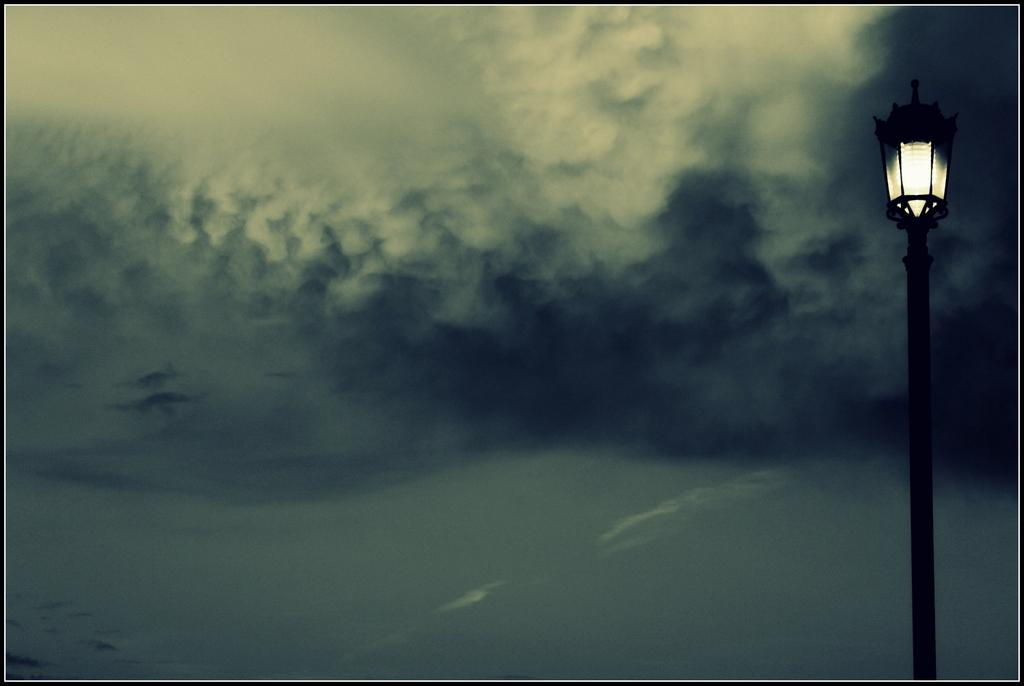What structure is present in the image? There is a light pole in the image. What can be seen in the background of the image? There are clouds and the sky visible in the background of the image. What type of letters are being sent from the church in the image? There is no church or letters present in the image; it only features a light pole and the sky in the background. 